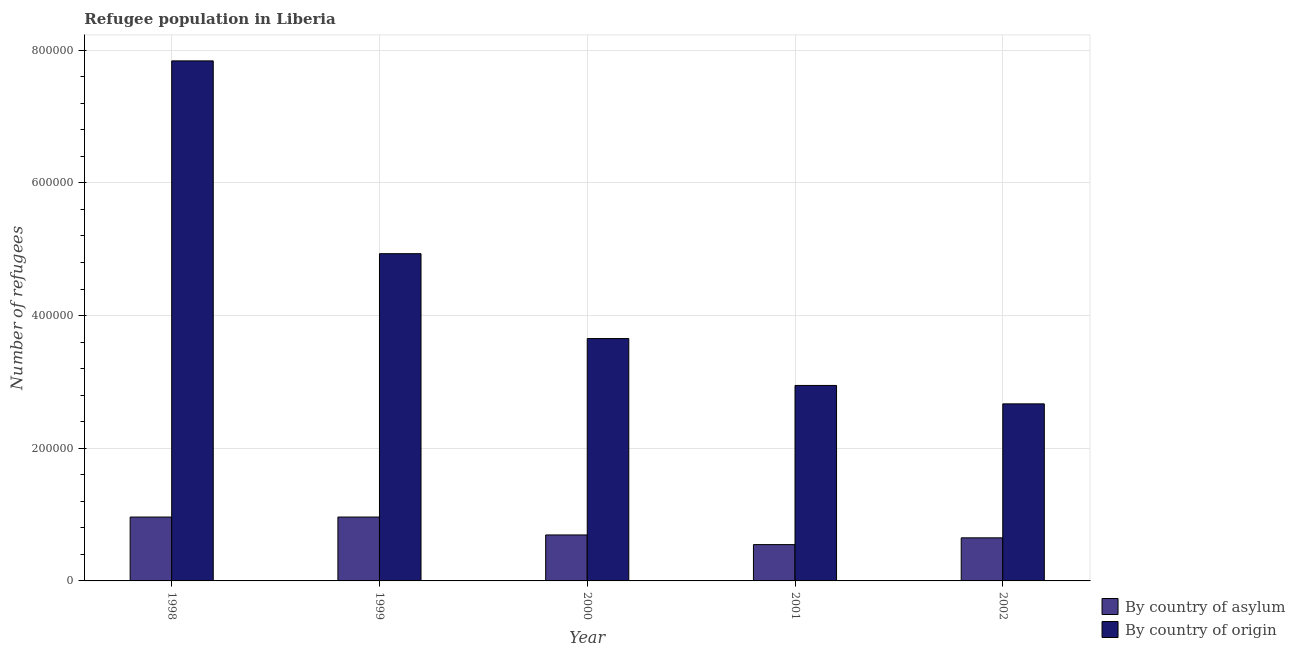How many different coloured bars are there?
Make the answer very short. 2. How many groups of bars are there?
Provide a short and direct response. 5. How many bars are there on the 5th tick from the left?
Keep it short and to the point. 2. How many bars are there on the 3rd tick from the right?
Your answer should be compact. 2. What is the label of the 1st group of bars from the left?
Make the answer very short. 1998. What is the number of refugees by country of asylum in 2000?
Provide a succinct answer. 6.93e+04. Across all years, what is the maximum number of refugees by country of asylum?
Your response must be concise. 9.63e+04. Across all years, what is the minimum number of refugees by country of origin?
Make the answer very short. 2.67e+05. In which year was the number of refugees by country of asylum minimum?
Provide a short and direct response. 2001. What is the total number of refugees by country of asylum in the graph?
Your answer should be compact. 3.82e+05. What is the difference between the number of refugees by country of asylum in 1998 and that in 1999?
Ensure brevity in your answer.  0. What is the difference between the number of refugees by country of asylum in 2001 and the number of refugees by country of origin in 1998?
Give a very brief answer. -4.16e+04. What is the average number of refugees by country of origin per year?
Keep it short and to the point. 4.41e+05. In how many years, is the number of refugees by country of origin greater than 720000?
Offer a terse response. 1. What is the ratio of the number of refugees by country of origin in 2001 to that in 2002?
Provide a succinct answer. 1.1. What is the difference between the highest and the second highest number of refugees by country of origin?
Provide a succinct answer. 2.91e+05. What is the difference between the highest and the lowest number of refugees by country of origin?
Offer a terse response. 5.17e+05. In how many years, is the number of refugees by country of origin greater than the average number of refugees by country of origin taken over all years?
Provide a succinct answer. 2. Is the sum of the number of refugees by country of asylum in 1998 and 1999 greater than the maximum number of refugees by country of origin across all years?
Your answer should be compact. Yes. What does the 2nd bar from the left in 2001 represents?
Provide a short and direct response. By country of origin. What does the 2nd bar from the right in 1999 represents?
Your response must be concise. By country of asylum. How many bars are there?
Your response must be concise. 10. Does the graph contain grids?
Give a very brief answer. Yes. Where does the legend appear in the graph?
Your answer should be very brief. Bottom right. How are the legend labels stacked?
Provide a succinct answer. Vertical. What is the title of the graph?
Keep it short and to the point. Refugee population in Liberia. What is the label or title of the Y-axis?
Make the answer very short. Number of refugees. What is the Number of refugees of By country of asylum in 1998?
Offer a terse response. 9.63e+04. What is the Number of refugees in By country of origin in 1998?
Make the answer very short. 7.84e+05. What is the Number of refugees of By country of asylum in 1999?
Provide a short and direct response. 9.63e+04. What is the Number of refugees in By country of origin in 1999?
Offer a very short reply. 4.93e+05. What is the Number of refugees of By country of asylum in 2000?
Give a very brief answer. 6.93e+04. What is the Number of refugees in By country of origin in 2000?
Make the answer very short. 3.65e+05. What is the Number of refugees in By country of asylum in 2001?
Your answer should be very brief. 5.48e+04. What is the Number of refugees of By country of origin in 2001?
Keep it short and to the point. 2.95e+05. What is the Number of refugees in By country of asylum in 2002?
Provide a short and direct response. 6.50e+04. What is the Number of refugees of By country of origin in 2002?
Your answer should be very brief. 2.67e+05. Across all years, what is the maximum Number of refugees of By country of asylum?
Your answer should be very brief. 9.63e+04. Across all years, what is the maximum Number of refugees in By country of origin?
Your answer should be compact. 7.84e+05. Across all years, what is the minimum Number of refugees in By country of asylum?
Provide a succinct answer. 5.48e+04. Across all years, what is the minimum Number of refugees of By country of origin?
Provide a short and direct response. 2.67e+05. What is the total Number of refugees in By country of asylum in the graph?
Keep it short and to the point. 3.82e+05. What is the total Number of refugees in By country of origin in the graph?
Your response must be concise. 2.20e+06. What is the difference between the Number of refugees in By country of origin in 1998 and that in 1999?
Ensure brevity in your answer.  2.91e+05. What is the difference between the Number of refugees of By country of asylum in 1998 and that in 2000?
Provide a succinct answer. 2.70e+04. What is the difference between the Number of refugees of By country of origin in 1998 and that in 2000?
Give a very brief answer. 4.19e+05. What is the difference between the Number of refugees in By country of asylum in 1998 and that in 2001?
Offer a very short reply. 4.16e+04. What is the difference between the Number of refugees in By country of origin in 1998 and that in 2001?
Your answer should be very brief. 4.89e+05. What is the difference between the Number of refugees in By country of asylum in 1998 and that in 2002?
Your answer should be compact. 3.14e+04. What is the difference between the Number of refugees of By country of origin in 1998 and that in 2002?
Keep it short and to the point. 5.17e+05. What is the difference between the Number of refugees in By country of asylum in 1999 and that in 2000?
Your response must be concise. 2.70e+04. What is the difference between the Number of refugees in By country of origin in 1999 and that in 2000?
Make the answer very short. 1.28e+05. What is the difference between the Number of refugees in By country of asylum in 1999 and that in 2001?
Ensure brevity in your answer.  4.16e+04. What is the difference between the Number of refugees of By country of origin in 1999 and that in 2001?
Offer a very short reply. 1.99e+05. What is the difference between the Number of refugees of By country of asylum in 1999 and that in 2002?
Your answer should be compact. 3.14e+04. What is the difference between the Number of refugees in By country of origin in 1999 and that in 2002?
Offer a very short reply. 2.26e+05. What is the difference between the Number of refugees in By country of asylum in 2000 and that in 2001?
Offer a very short reply. 1.46e+04. What is the difference between the Number of refugees in By country of origin in 2000 and that in 2001?
Give a very brief answer. 7.07e+04. What is the difference between the Number of refugees of By country of asylum in 2000 and that in 2002?
Provide a succinct answer. 4359. What is the difference between the Number of refugees of By country of origin in 2000 and that in 2002?
Give a very brief answer. 9.85e+04. What is the difference between the Number of refugees of By country of asylum in 2001 and that in 2002?
Your answer should be compact. -1.02e+04. What is the difference between the Number of refugees in By country of origin in 2001 and that in 2002?
Your response must be concise. 2.78e+04. What is the difference between the Number of refugees of By country of asylum in 1998 and the Number of refugees of By country of origin in 1999?
Your answer should be compact. -3.97e+05. What is the difference between the Number of refugees of By country of asylum in 1998 and the Number of refugees of By country of origin in 2000?
Your answer should be very brief. -2.69e+05. What is the difference between the Number of refugees of By country of asylum in 1998 and the Number of refugees of By country of origin in 2001?
Your answer should be very brief. -1.98e+05. What is the difference between the Number of refugees in By country of asylum in 1998 and the Number of refugees in By country of origin in 2002?
Your answer should be compact. -1.71e+05. What is the difference between the Number of refugees of By country of asylum in 1999 and the Number of refugees of By country of origin in 2000?
Provide a short and direct response. -2.69e+05. What is the difference between the Number of refugees in By country of asylum in 1999 and the Number of refugees in By country of origin in 2001?
Give a very brief answer. -1.98e+05. What is the difference between the Number of refugees of By country of asylum in 1999 and the Number of refugees of By country of origin in 2002?
Your answer should be compact. -1.71e+05. What is the difference between the Number of refugees in By country of asylum in 2000 and the Number of refugees in By country of origin in 2001?
Ensure brevity in your answer.  -2.25e+05. What is the difference between the Number of refugees of By country of asylum in 2000 and the Number of refugees of By country of origin in 2002?
Ensure brevity in your answer.  -1.98e+05. What is the difference between the Number of refugees in By country of asylum in 2001 and the Number of refugees in By country of origin in 2002?
Offer a very short reply. -2.12e+05. What is the average Number of refugees of By country of asylum per year?
Ensure brevity in your answer.  7.63e+04. What is the average Number of refugees of By country of origin per year?
Your response must be concise. 4.41e+05. In the year 1998, what is the difference between the Number of refugees in By country of asylum and Number of refugees in By country of origin?
Your answer should be compact. -6.88e+05. In the year 1999, what is the difference between the Number of refugees in By country of asylum and Number of refugees in By country of origin?
Ensure brevity in your answer.  -3.97e+05. In the year 2000, what is the difference between the Number of refugees in By country of asylum and Number of refugees in By country of origin?
Your response must be concise. -2.96e+05. In the year 2001, what is the difference between the Number of refugees in By country of asylum and Number of refugees in By country of origin?
Provide a succinct answer. -2.40e+05. In the year 2002, what is the difference between the Number of refugees of By country of asylum and Number of refugees of By country of origin?
Offer a very short reply. -2.02e+05. What is the ratio of the Number of refugees of By country of origin in 1998 to that in 1999?
Your answer should be compact. 1.59. What is the ratio of the Number of refugees in By country of asylum in 1998 to that in 2000?
Keep it short and to the point. 1.39. What is the ratio of the Number of refugees in By country of origin in 1998 to that in 2000?
Your answer should be very brief. 2.15. What is the ratio of the Number of refugees of By country of asylum in 1998 to that in 2001?
Offer a terse response. 1.76. What is the ratio of the Number of refugees of By country of origin in 1998 to that in 2001?
Offer a very short reply. 2.66. What is the ratio of the Number of refugees of By country of asylum in 1998 to that in 2002?
Ensure brevity in your answer.  1.48. What is the ratio of the Number of refugees of By country of origin in 1998 to that in 2002?
Your response must be concise. 2.94. What is the ratio of the Number of refugees in By country of asylum in 1999 to that in 2000?
Your response must be concise. 1.39. What is the ratio of the Number of refugees of By country of origin in 1999 to that in 2000?
Offer a terse response. 1.35. What is the ratio of the Number of refugees of By country of asylum in 1999 to that in 2001?
Give a very brief answer. 1.76. What is the ratio of the Number of refugees in By country of origin in 1999 to that in 2001?
Your response must be concise. 1.67. What is the ratio of the Number of refugees of By country of asylum in 1999 to that in 2002?
Make the answer very short. 1.48. What is the ratio of the Number of refugees in By country of origin in 1999 to that in 2002?
Offer a terse response. 1.85. What is the ratio of the Number of refugees of By country of asylum in 2000 to that in 2001?
Offer a very short reply. 1.27. What is the ratio of the Number of refugees in By country of origin in 2000 to that in 2001?
Your response must be concise. 1.24. What is the ratio of the Number of refugees in By country of asylum in 2000 to that in 2002?
Offer a very short reply. 1.07. What is the ratio of the Number of refugees in By country of origin in 2000 to that in 2002?
Keep it short and to the point. 1.37. What is the ratio of the Number of refugees in By country of asylum in 2001 to that in 2002?
Offer a very short reply. 0.84. What is the ratio of the Number of refugees of By country of origin in 2001 to that in 2002?
Your response must be concise. 1.1. What is the difference between the highest and the second highest Number of refugees of By country of asylum?
Give a very brief answer. 0. What is the difference between the highest and the second highest Number of refugees of By country of origin?
Your answer should be compact. 2.91e+05. What is the difference between the highest and the lowest Number of refugees of By country of asylum?
Offer a very short reply. 4.16e+04. What is the difference between the highest and the lowest Number of refugees of By country of origin?
Your answer should be very brief. 5.17e+05. 